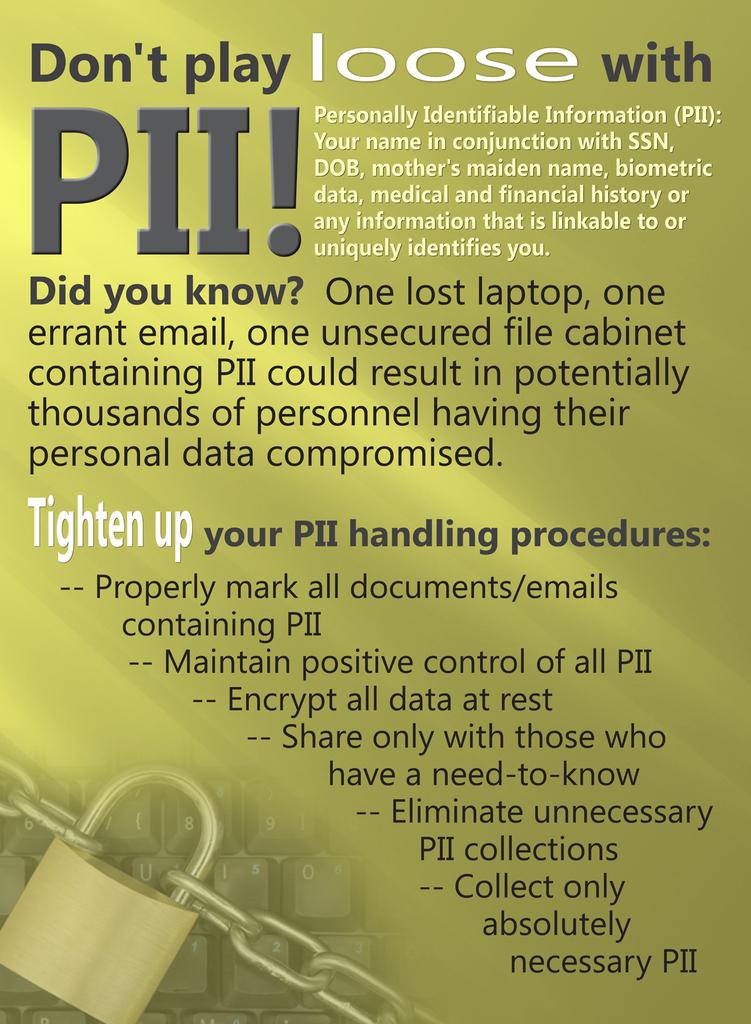Don't play loose with what?
Ensure brevity in your answer.  Pii. What do you need to tighten up?
Give a very brief answer. Your pii handling procedures. 